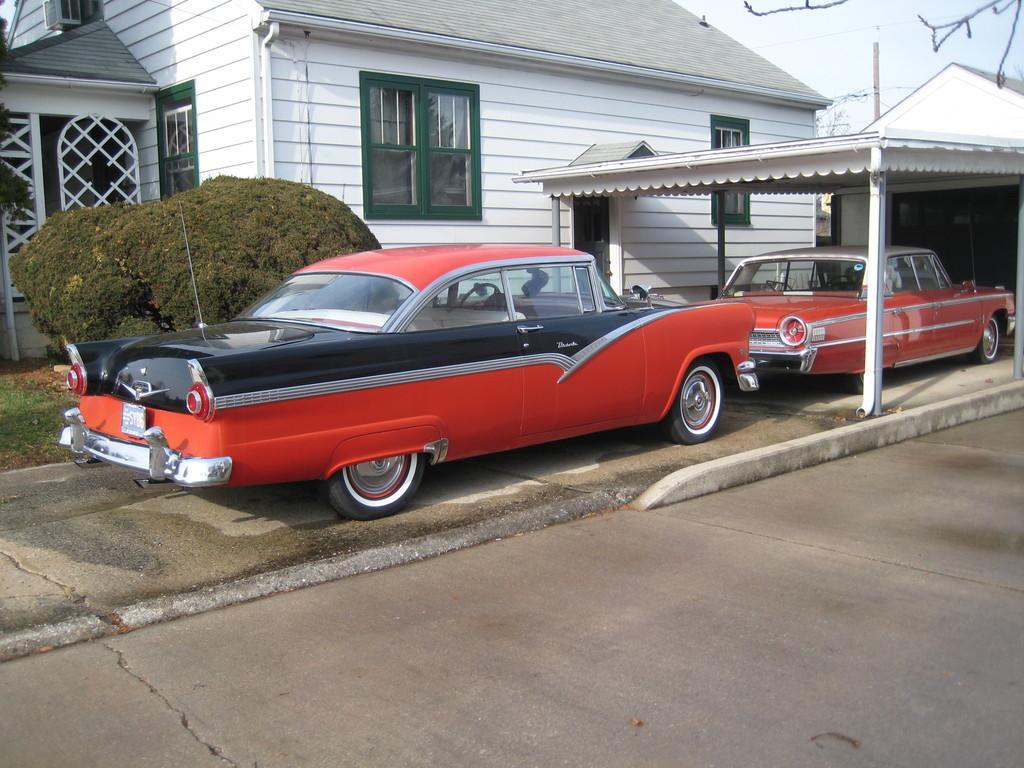In one or two sentences, can you explain what this image depicts? This image is clicked outside. There are cars in the middle. They are in orange color. There are bushes on the left side. There is a building in the middle. It has windows, doors. There is sky at the top. 